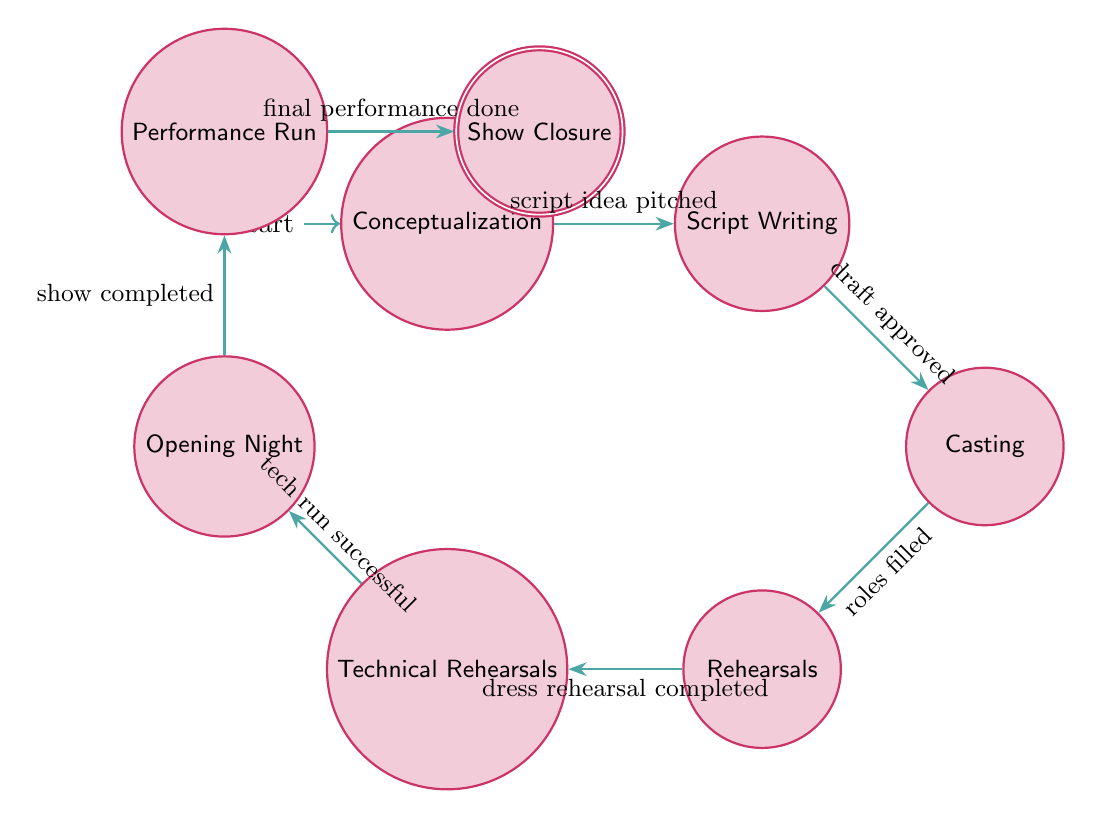What is the first state in the diagram? The first state in the diagram is labeled "Conceptualization." It is the initial state, where the process begins.
Answer: Conceptualization How many states are there in total? Counting the states listed in the diagram, there are eight states: Conceptualization, Script Writing, Casting, Rehearsals, Technical Rehearsals, Opening Night, Performance Run, and Show Closure.
Answer: Eight What transition connects Script Writing to the next state? The transition from Script Writing to the next state, which is Casting, is labeled "draft approved." This indicates progression after the script has been written and approved.
Answer: draft approved Which state follows Technical Rehearsals? After Technical Rehearsals, the next state is Opening Night. According to the diagram, this progression relies on the success of the technical runs.
Answer: Opening Night In which state does the final performance take place? The final performance occurs in the state labeled "Performance Run." This indicates the show has been successfully opened and is now being performed.
Answer: Performance Run What event leads to Show Closure? The event that leads to Show Closure is labeled "final performance done." This indicates that all performances have been completed, and the process is concluding.
Answer: final performance done Which state precedes Rehearsals? The state that directly precedes Rehearsals is Casting. It represents the phase where roles are filled before moving into rehearsals.
Answer: Casting How many transitions are there leading out of the Opening Night? There is one transition leading out of the Opening Night, which is labeled "show completed." It represents the completion of the opening performance before moving to the next state.
Answer: One What is the last state in the diagram? The last state in the diagram is labeled "Show Closure." It indicates the final phase of the theater production workflow, signifying the end of the process.
Answer: Show Closure 